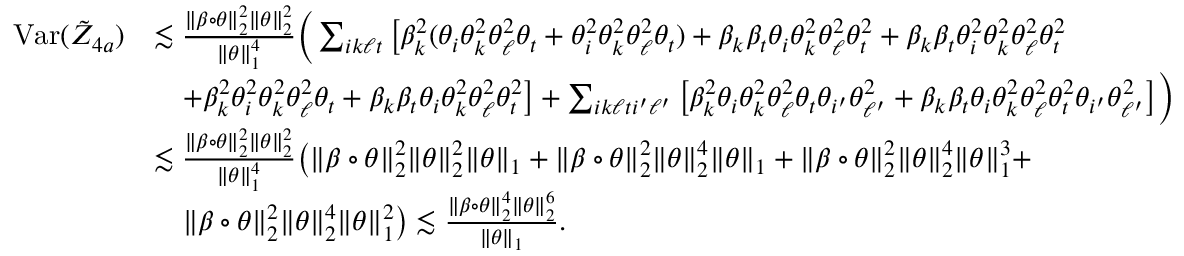Convert formula to latex. <formula><loc_0><loc_0><loc_500><loc_500>\begin{array} { r l } { V a r ( \tilde { Z } _ { 4 a } ) } & { \lesssim \frac { \| \beta \circ \theta \| _ { 2 } ^ { 2 } \| \theta \| _ { 2 } ^ { 2 } } { \| \theta \| _ { 1 } ^ { 4 } } \left ( \sum _ { i k \ell t } \left [ \beta _ { k } ^ { 2 } ( \theta _ { i } \theta _ { k } ^ { 2 } \theta _ { \ell } ^ { 2 } \theta _ { t } + \theta _ { i } ^ { 2 } \theta _ { k } ^ { 2 } \theta _ { \ell } ^ { 2 } \theta _ { t } ) + \beta _ { k } \beta _ { t } \theta _ { i } \theta _ { k } ^ { 2 } \theta _ { \ell } ^ { 2 } \theta _ { t } ^ { 2 } + \beta _ { k } \beta _ { t } \theta _ { i } ^ { 2 } \theta _ { k } ^ { 2 } \theta _ { \ell } ^ { 2 } \theta _ { t } ^ { 2 } } \\ & { \quad + \beta _ { k } ^ { 2 } \theta _ { i } ^ { 2 } \theta _ { k } ^ { 2 } \theta _ { \ell } ^ { 2 } \theta _ { t } + \beta _ { k } \beta _ { t } \theta _ { i } \theta _ { k } ^ { 2 } \theta _ { \ell } ^ { 2 } \theta _ { t } ^ { 2 } \right ] + \sum _ { i k \ell t i ^ { \prime } \ell ^ { \prime } } \left [ \beta _ { k } ^ { 2 } \theta _ { i } \theta _ { k } ^ { 2 } \theta _ { \ell } ^ { 2 } \theta _ { t } \theta _ { i ^ { \prime } } \theta _ { \ell ^ { \prime } } ^ { 2 } + \beta _ { k } \beta _ { t } \theta _ { i } \theta _ { k } ^ { 2 } \theta _ { \ell } ^ { 2 } \theta _ { t } ^ { 2 } \theta _ { i ^ { \prime } } \theta _ { \ell ^ { \prime } } ^ { 2 } \right ] \right ) } \\ & { \lesssim \frac { \| \beta \circ \theta \| _ { 2 } ^ { 2 } \| \theta \| _ { 2 } ^ { 2 } } { \| \theta \| _ { 1 } ^ { 4 } } \left ( \| \beta \circ \theta \| _ { 2 } ^ { 2 } \| \theta \| _ { 2 } ^ { 2 } \| \theta \| _ { 1 } + \| \beta \circ \theta \| _ { 2 } ^ { 2 } \| \theta \| _ { 2 } ^ { 4 } \| \theta \| _ { 1 } + \| \beta \circ \theta \| _ { 2 } ^ { 2 } \| \theta \| _ { 2 } ^ { 4 } \| \theta \| _ { 1 } ^ { 3 } + } \\ & { \quad \| \beta \circ \theta \| _ { 2 } ^ { 2 } \| \theta \| _ { 2 } ^ { 4 } \| \theta \| _ { 1 } ^ { 2 } \right ) \lesssim \frac { \| \beta \circ \theta \| _ { 2 } ^ { 4 } \| \theta \| _ { 2 } ^ { 6 } } { \| \theta \| _ { 1 } } . } \end{array}</formula> 